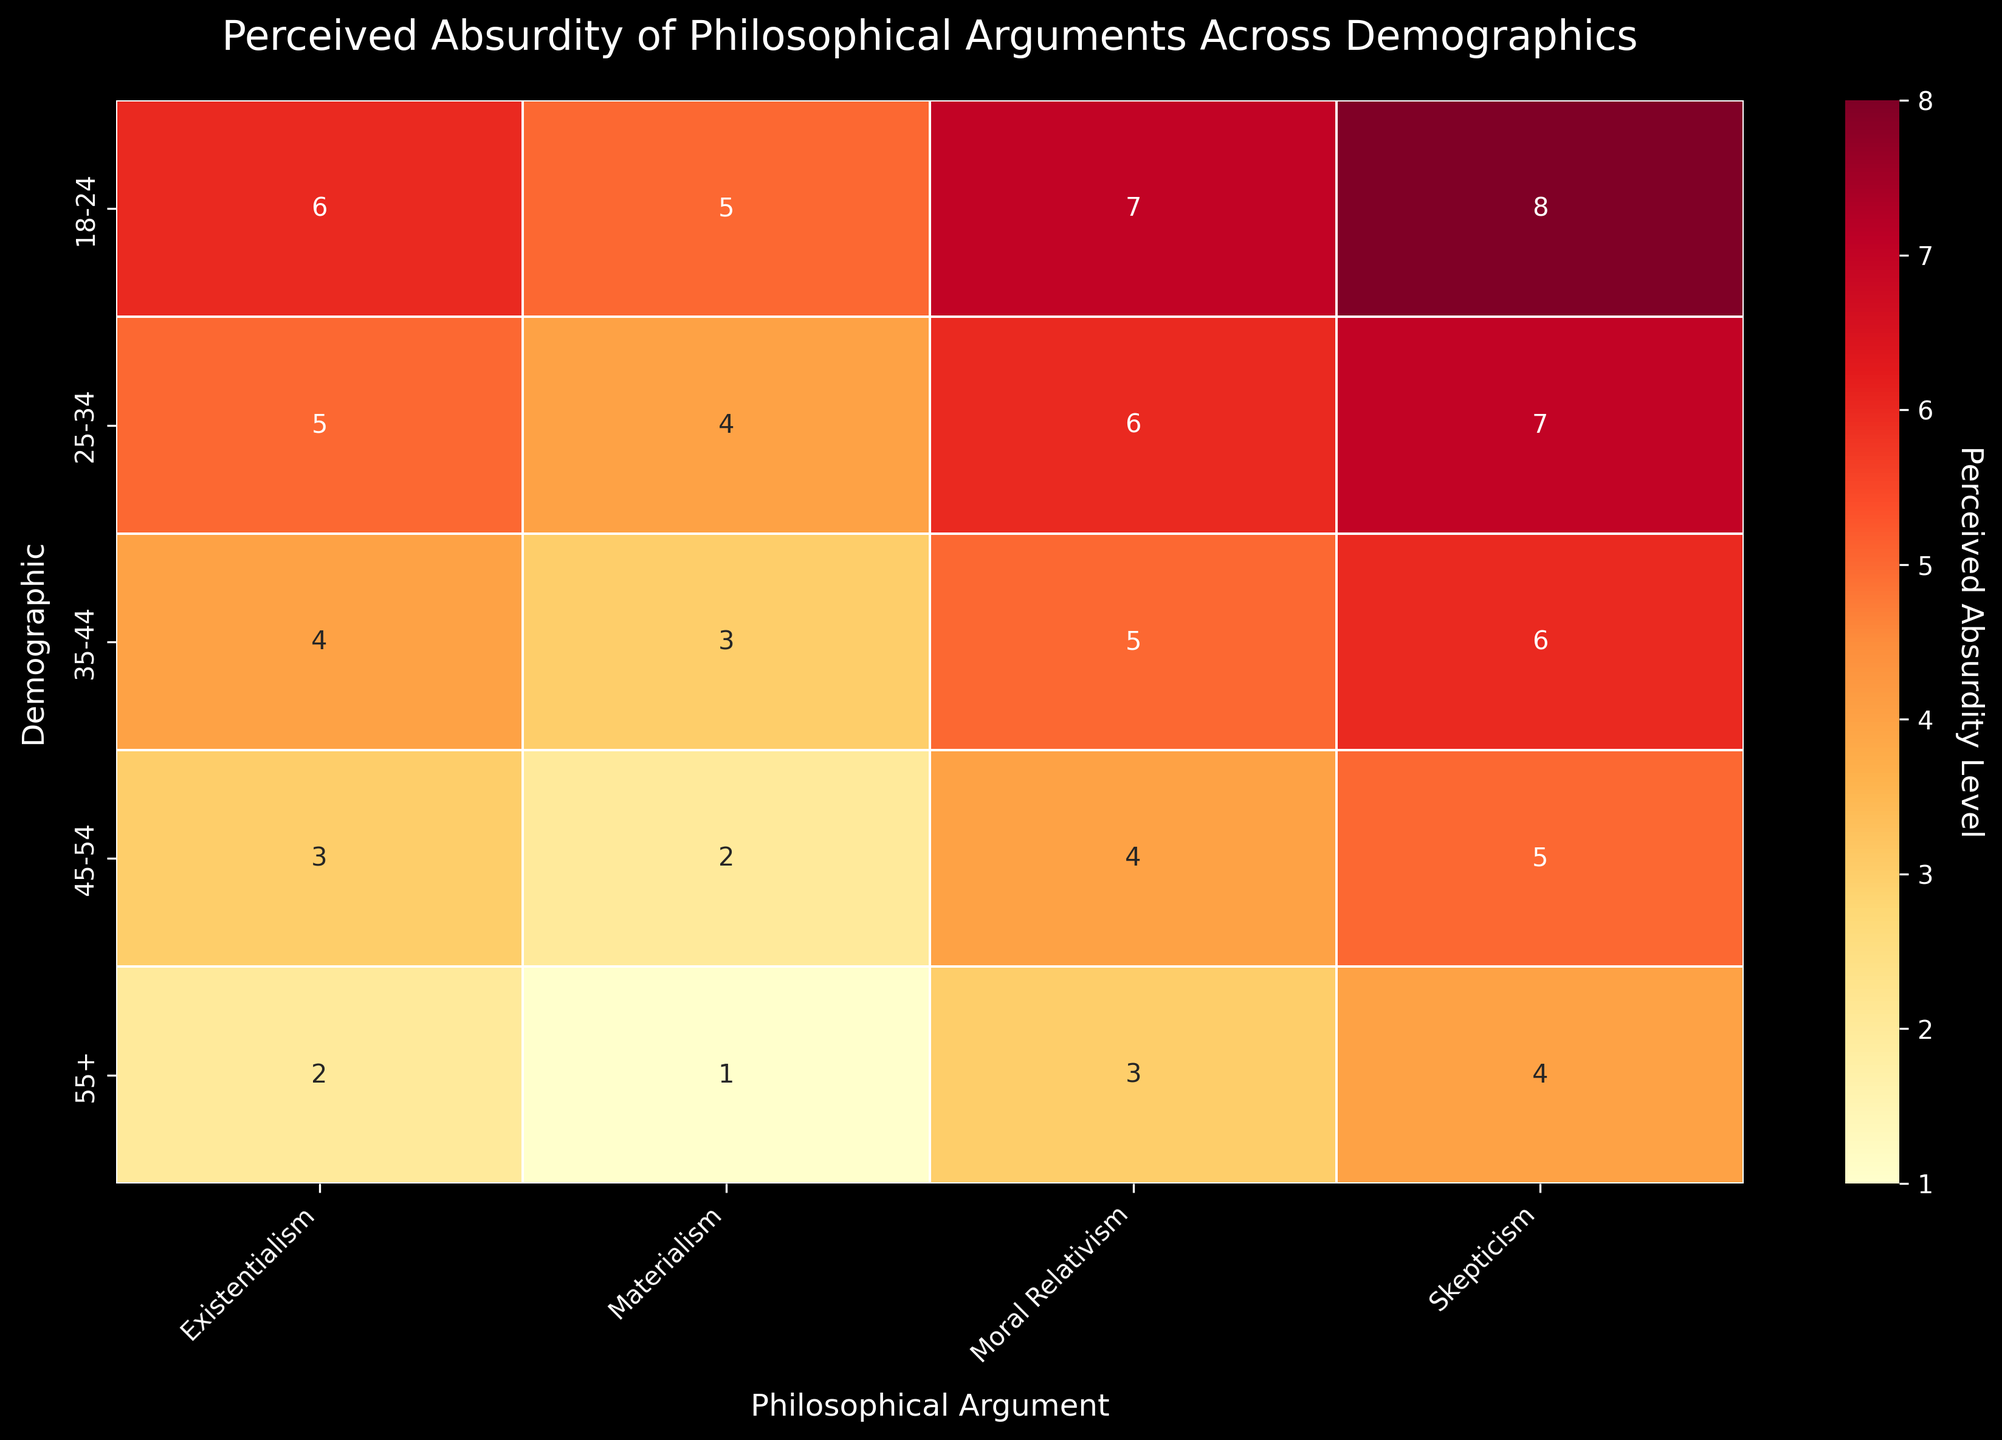What is the title of the heatmap? Look at the top center of the heatmap, where the title is located.
Answer: "Perceived Absurdity of Philosophical Arguments Across Demographics" Which demographic group perceives "Skepticism" as the most absurd? Check the values in the "Skepticism" column and find the highest value. The highest value is 8, located in the 18-24 demographic row.
Answer: 18-24 What is the perceived absurdity of "Materialism" among the 35-44 demographic? Locate the row for the 35-44 demographic and the column for "Materialism," and read the intersecting value, which is 3.
Answer: 3 How does the perceived absurdity of "Existentialism" change from the 18-24 to the 55+ demographic? Compare the values in the "Existentialism" column from the 18-24 row (6) to the 55+ row (2).
Answer: It decreases by 4 Which philosophical argument has the lowest average perceived absurdity level across all demographics? Calculate the average perceived absurdity for each column: Moral Relativism (5), Materialism (3), Skepticism (6), Existentialism (4); then find the lowest average value, which is for Materialism.
Answer: Materialism Which age group perceives "Moral Relativism" as less absurd compared to "Skepticism"? Compare the values for "Moral Relativism" and "Skepticism" in each demographic row and find where the value for "Moral Relativism" is less. The "55+" demographic perceives "Moral Relativism" (3) as less absurd than "Skepticism" (4).
Answer: 55+ What's the sum of perceived absurdity levels for the "25-34" demographic across all philosophical arguments? Sum the values in the "25-34" row: Moral Relativism (6) + Materialism (4) + Skepticism (7) + Existentialism (5) = 22.
Answer: 22 Which philosophical argument is perceived as increasingly absurd among younger demographics (18-24 and 25-34)? Compare the values of "18-24" and "25-34" for each philosophical argument: Moral Relativism (7 → 6), Materialism (5 → 4), Skepticism (8 → 7), Existentialism (6 → 5); Skepticism has the highest perceived absurdity in both categories with 7, 8.
Answer: Skepticism How does the perceived absurdity of "Moral Relativism" change across all demographic groups? Look at the values in the "Moral Relativism" column for each demographic group: 18-24 (7), 25-34 (6), 35-44 (5), 45-54 (4), 55+ (3); it decreases step-wise by 1 as demographics age.
Answer: It decreases by 1 across each group Which demographic group has the lowest perceived absurdity overall? Sum the values for each row and find the lowest total: 18-24 (26), 25-34 (22), 35-44 (18), 45-54 (14), 55+ (10). The "55+" demographic has the lowest sum, indicating the lowest perceived absurdity overall.
Answer: 55+ 